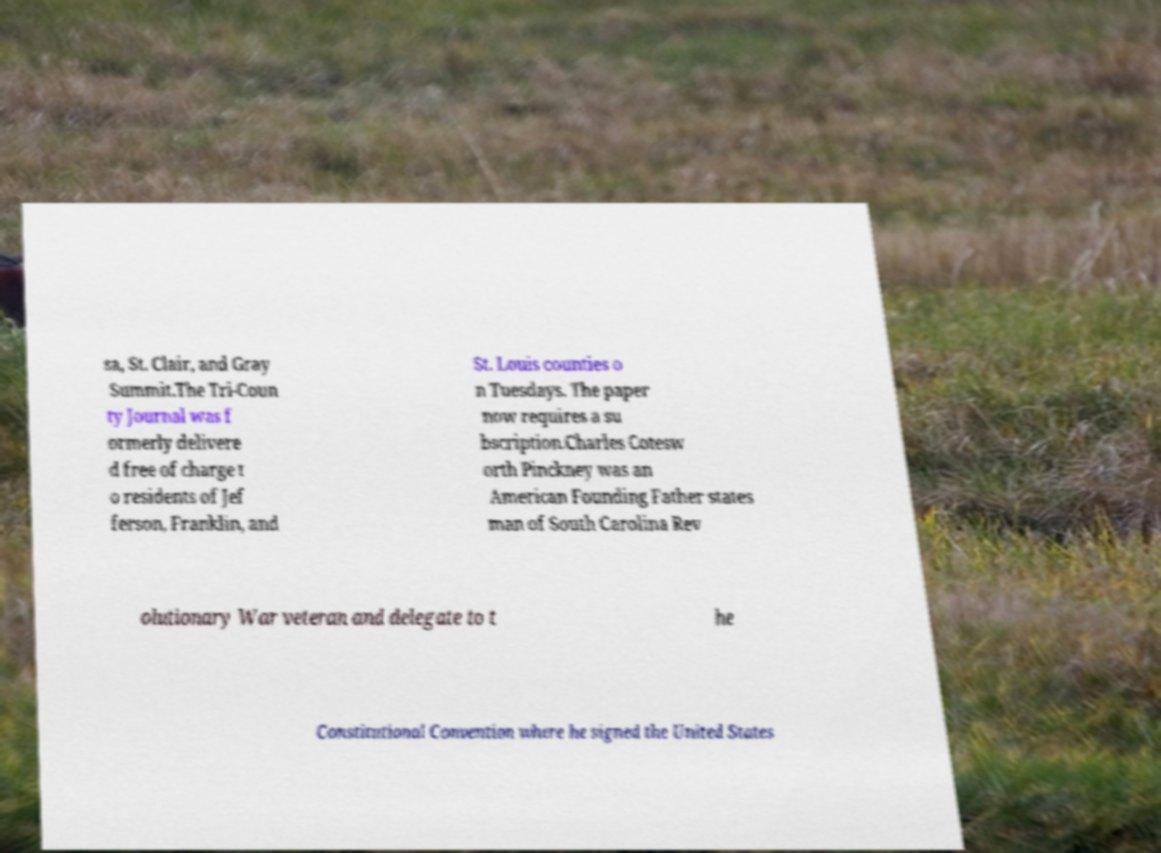Please identify and transcribe the text found in this image. sa, St. Clair, and Gray Summit.The Tri-Coun ty Journal was f ormerly delivere d free of charge t o residents of Jef ferson, Franklin, and St. Louis counties o n Tuesdays. The paper now requires a su bscription.Charles Cotesw orth Pinckney was an American Founding Father states man of South Carolina Rev olutionary War veteran and delegate to t he Constitutional Convention where he signed the United States 